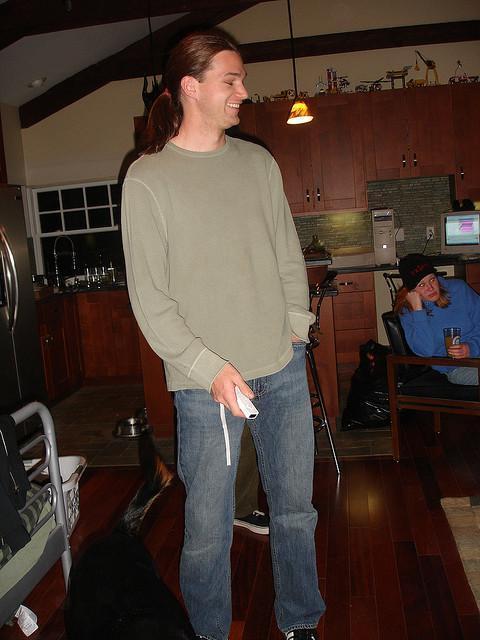How many people can you see?
Give a very brief answer. 2. 